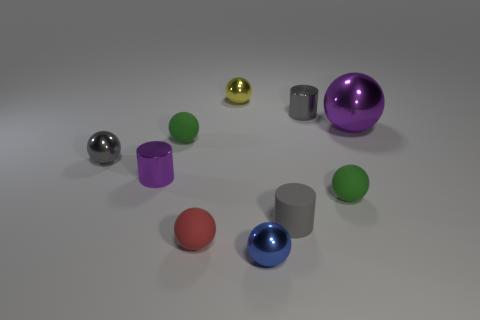The tiny metallic cylinder behind the large shiny sphere is what color?
Your answer should be very brief. Gray. Is the size of the green rubber object to the left of the gray matte object the same as the purple object that is in front of the tiny gray sphere?
Give a very brief answer. Yes. Is there a rubber block of the same size as the red object?
Your answer should be very brief. No. There is a tiny green matte sphere right of the yellow object; what number of green objects are on the left side of it?
Your response must be concise. 1. What is the material of the small purple cylinder?
Keep it short and to the point. Metal. There is a large purple sphere; how many purple shiny spheres are right of it?
Offer a terse response. 0. Does the big ball have the same color as the tiny rubber cylinder?
Keep it short and to the point. No. What number of cylinders are the same color as the large metallic ball?
Provide a succinct answer. 1. Is the number of big purple cylinders greater than the number of tiny blue metal objects?
Your answer should be compact. No. What size is the metal sphere that is both in front of the purple ball and right of the gray sphere?
Ensure brevity in your answer.  Small. 